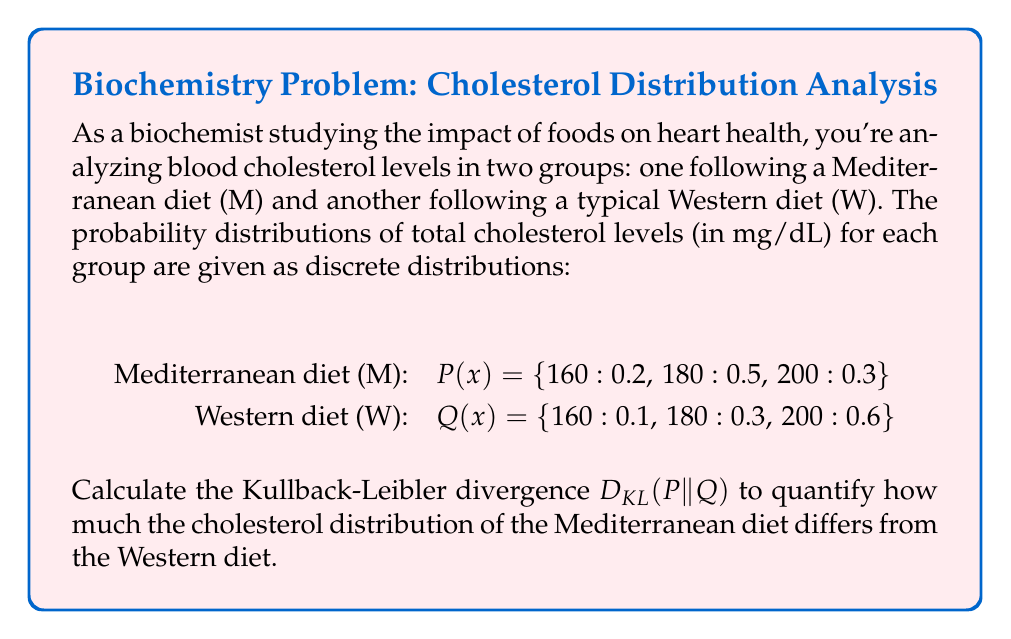Provide a solution to this math problem. To calculate the Kullback-Leibler divergence D_KL(P||Q), we'll use the formula:

$$D_{KL}(P||Q) = \sum_{x} P(x) \log_2 \frac{P(x)}{Q(x)}$$

Let's calculate this step-by-step:

1) For x = 160:
   $$P(160) \log_2 \frac{P(160)}{Q(160)} = 0.2 \log_2 \frac{0.2}{0.1} = 0.2 \log_2 2 = 0.2 \cdot 1 = 0.2$$

2) For x = 180:
   $$P(180) \log_2 \frac{P(180)}{Q(180)} = 0.5 \log_2 \frac{0.5}{0.3} \approx 0.5 \cdot 0.7370 = 0.3685$$

3) For x = 200:
   $$P(200) \log_2 \frac{P(200)}{Q(200)} = 0.3 \log_2 \frac{0.3}{0.6} = 0.3 \log_2 0.5 = 0.3 \cdot (-1) = -0.3$$

4) Sum all these values:
   $$D_{KL}(P||Q) = 0.2 + 0.3685 + (-0.3) = 0.2685$$

Therefore, the Kullback-Leibler divergence D_KL(P||Q) is approximately 0.2685 bits.
Answer: 0.2685 bits 